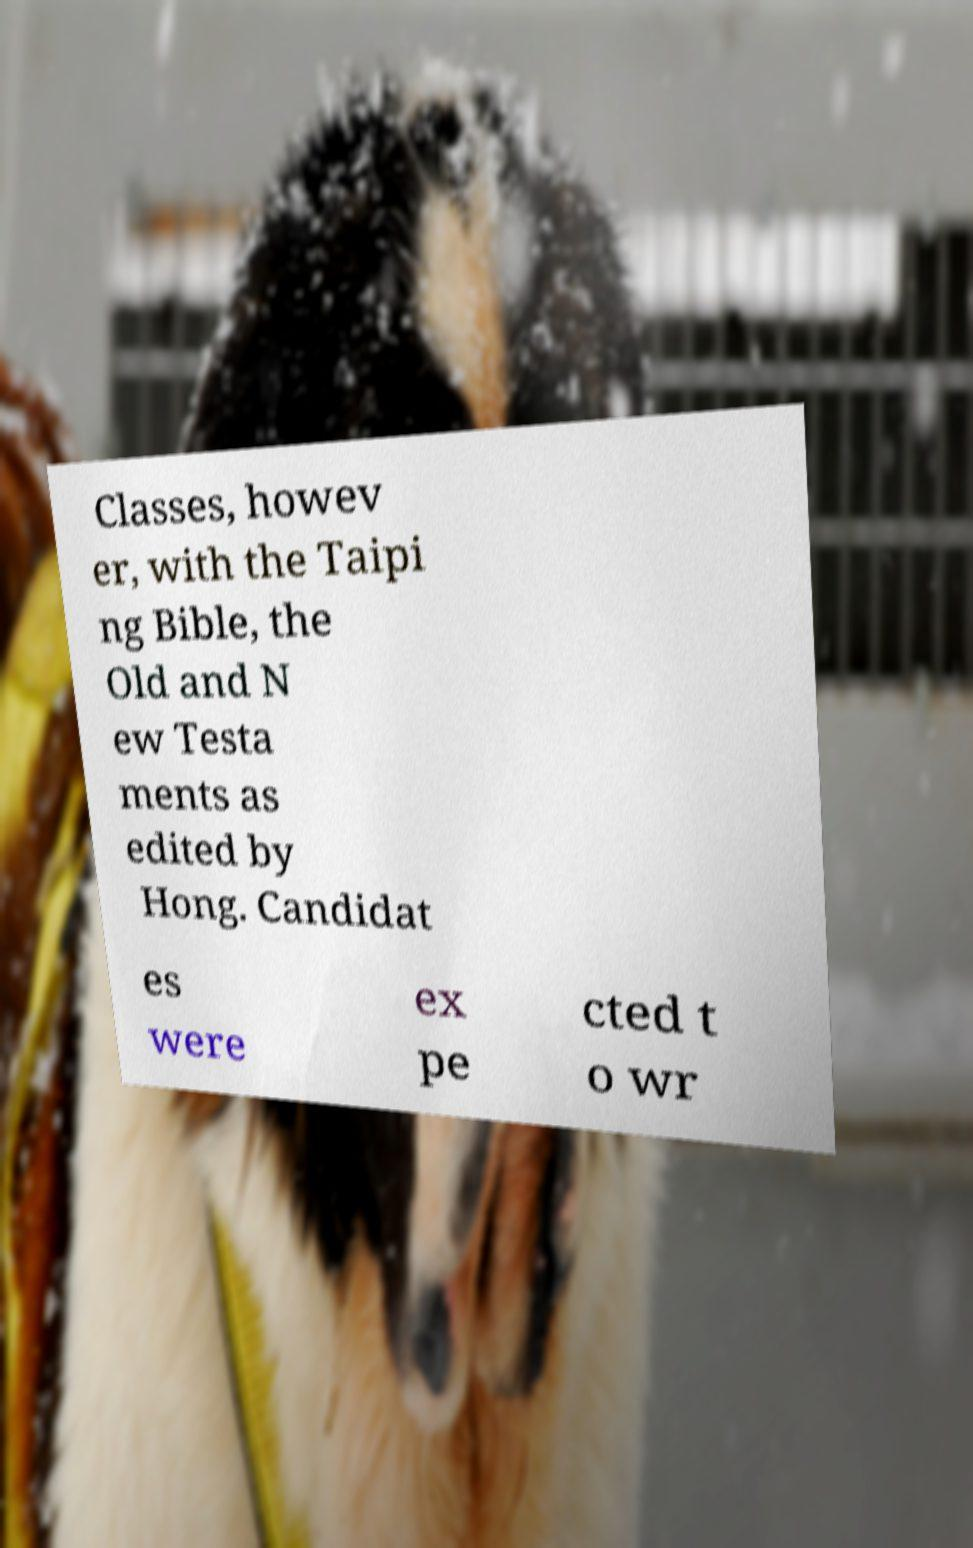I need the written content from this picture converted into text. Can you do that? Classes, howev er, with the Taipi ng Bible, the Old and N ew Testa ments as edited by Hong. Candidat es were ex pe cted t o wr 